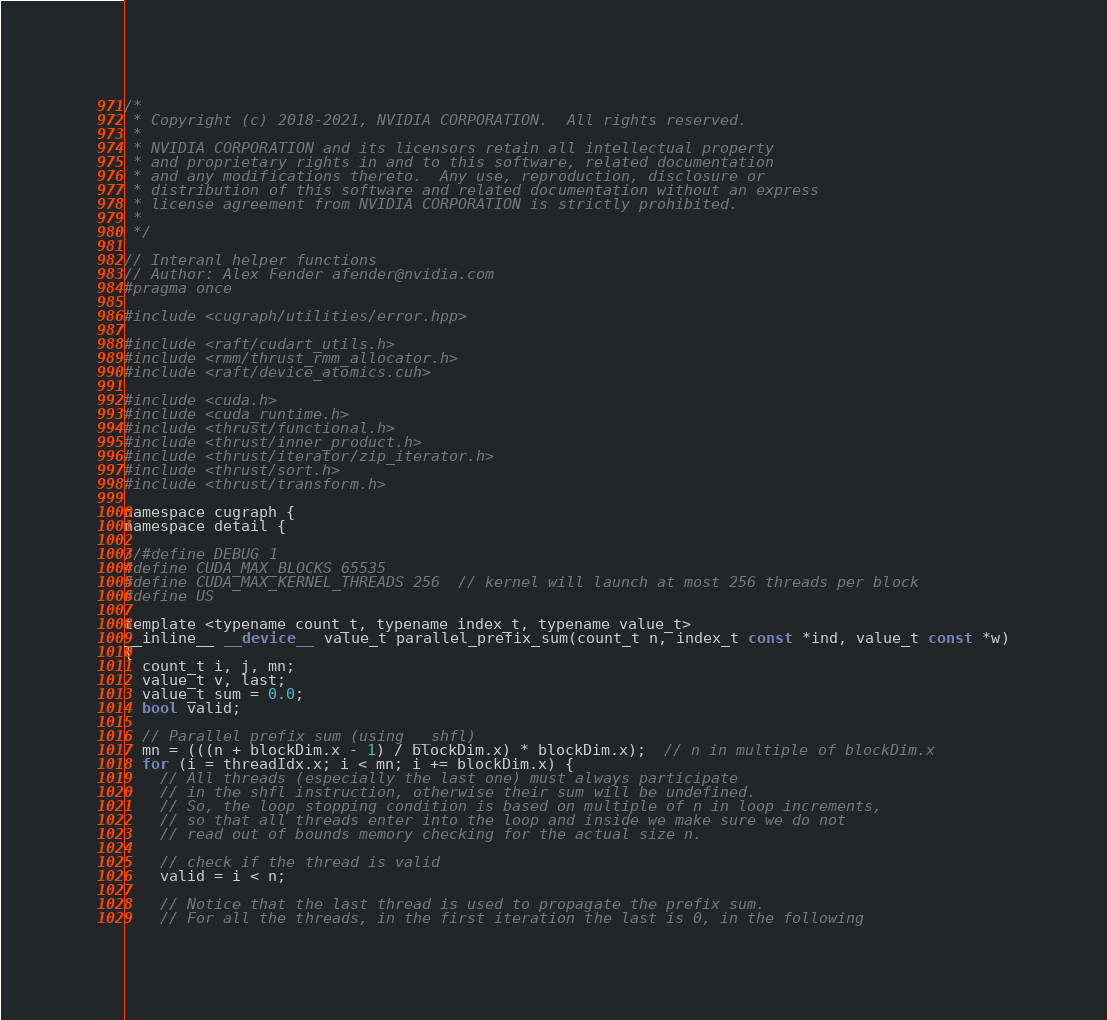Convert code to text. <code><loc_0><loc_0><loc_500><loc_500><_Cuda_>/*
 * Copyright (c) 2018-2021, NVIDIA CORPORATION.  All rights reserved.
 *
 * NVIDIA CORPORATION and its licensors retain all intellectual property
 * and proprietary rights in and to this software, related documentation
 * and any modifications thereto.  Any use, reproduction, disclosure or
 * distribution of this software and related documentation without an express
 * license agreement from NVIDIA CORPORATION is strictly prohibited.
 *
 */

// Interanl helper functions
// Author: Alex Fender afender@nvidia.com
#pragma once

#include <cugraph/utilities/error.hpp>

#include <raft/cudart_utils.h>
#include <rmm/thrust_rmm_allocator.h>
#include <raft/device_atomics.cuh>

#include <cuda.h>
#include <cuda_runtime.h>
#include <thrust/functional.h>
#include <thrust/inner_product.h>
#include <thrust/iterator/zip_iterator.h>
#include <thrust/sort.h>
#include <thrust/transform.h>

namespace cugraph {
namespace detail {

//#define DEBUG 1
#define CUDA_MAX_BLOCKS 65535
#define CUDA_MAX_KERNEL_THREADS 256  // kernel will launch at most 256 threads per block
#define US

template <typename count_t, typename index_t, typename value_t>
__inline__ __device__ value_t parallel_prefix_sum(count_t n, index_t const *ind, value_t const *w)
{
  count_t i, j, mn;
  value_t v, last;
  value_t sum = 0.0;
  bool valid;

  // Parallel prefix sum (using __shfl)
  mn = (((n + blockDim.x - 1) / blockDim.x) * blockDim.x);  // n in multiple of blockDim.x
  for (i = threadIdx.x; i < mn; i += blockDim.x) {
    // All threads (especially the last one) must always participate
    // in the shfl instruction, otherwise their sum will be undefined.
    // So, the loop stopping condition is based on multiple of n in loop increments,
    // so that all threads enter into the loop and inside we make sure we do not
    // read out of bounds memory checking for the actual size n.

    // check if the thread is valid
    valid = i < n;

    // Notice that the last thread is used to propagate the prefix sum.
    // For all the threads, in the first iteration the last is 0, in the following</code> 